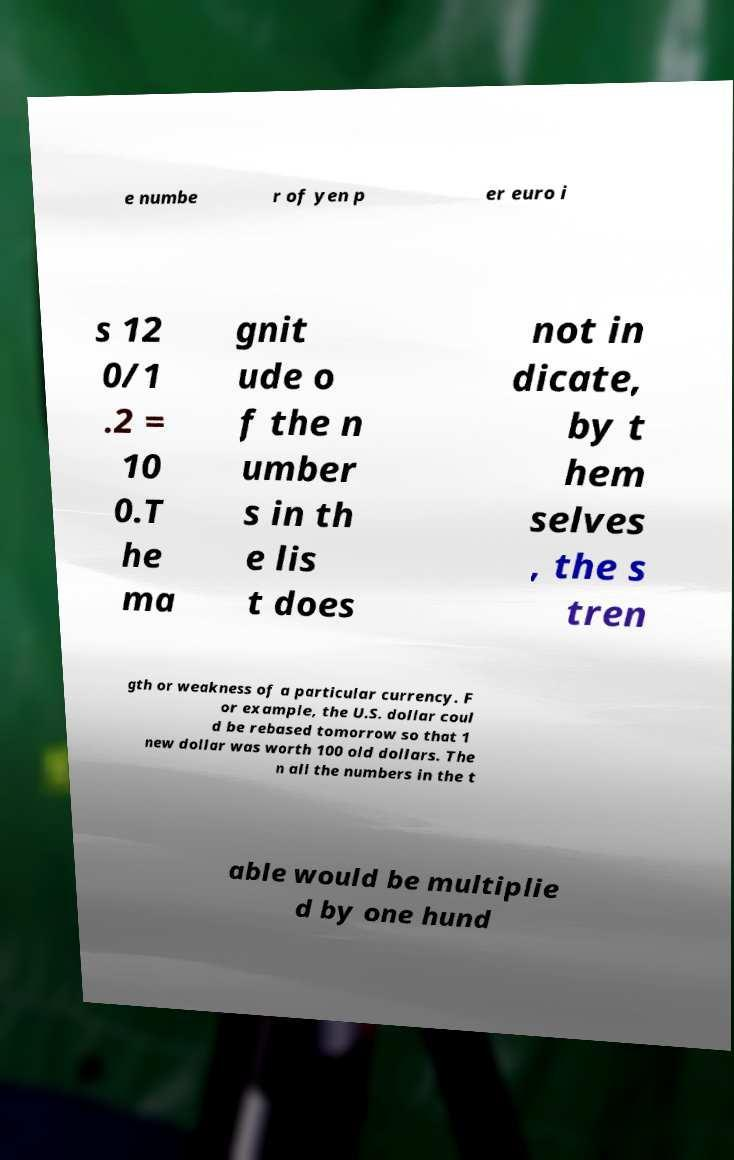Could you extract and type out the text from this image? e numbe r of yen p er euro i s 12 0/1 .2 = 10 0.T he ma gnit ude o f the n umber s in th e lis t does not in dicate, by t hem selves , the s tren gth or weakness of a particular currency. F or example, the U.S. dollar coul d be rebased tomorrow so that 1 new dollar was worth 100 old dollars. The n all the numbers in the t able would be multiplie d by one hund 